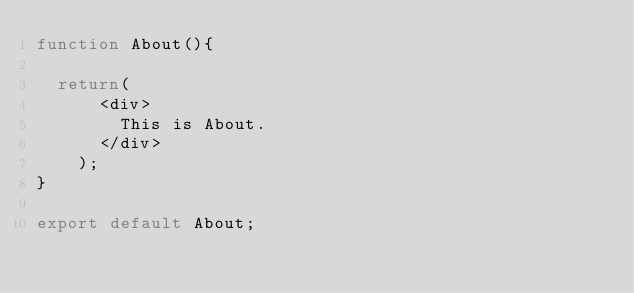Convert code to text. <code><loc_0><loc_0><loc_500><loc_500><_JavaScript_>function About(){

	return(
			<div>
				This is About.
			</div>
		);
}

export default About;</code> 